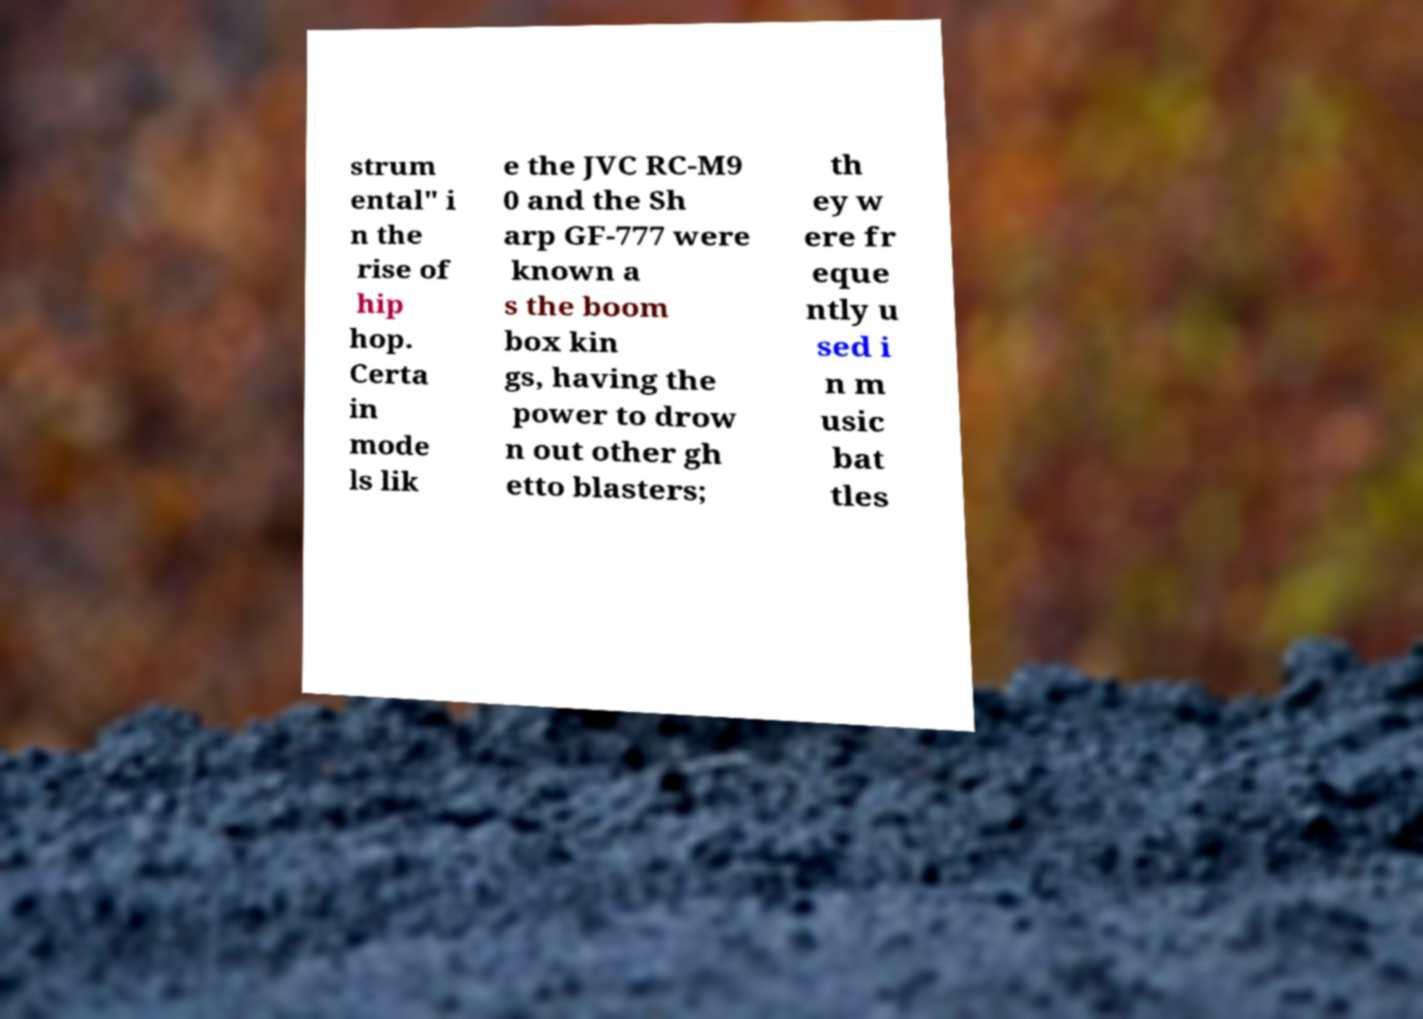Could you assist in decoding the text presented in this image and type it out clearly? strum ental" i n the rise of hip hop. Certa in mode ls lik e the JVC RC-M9 0 and the Sh arp GF-777 were known a s the boom box kin gs, having the power to drow n out other gh etto blasters; th ey w ere fr eque ntly u sed i n m usic bat tles 